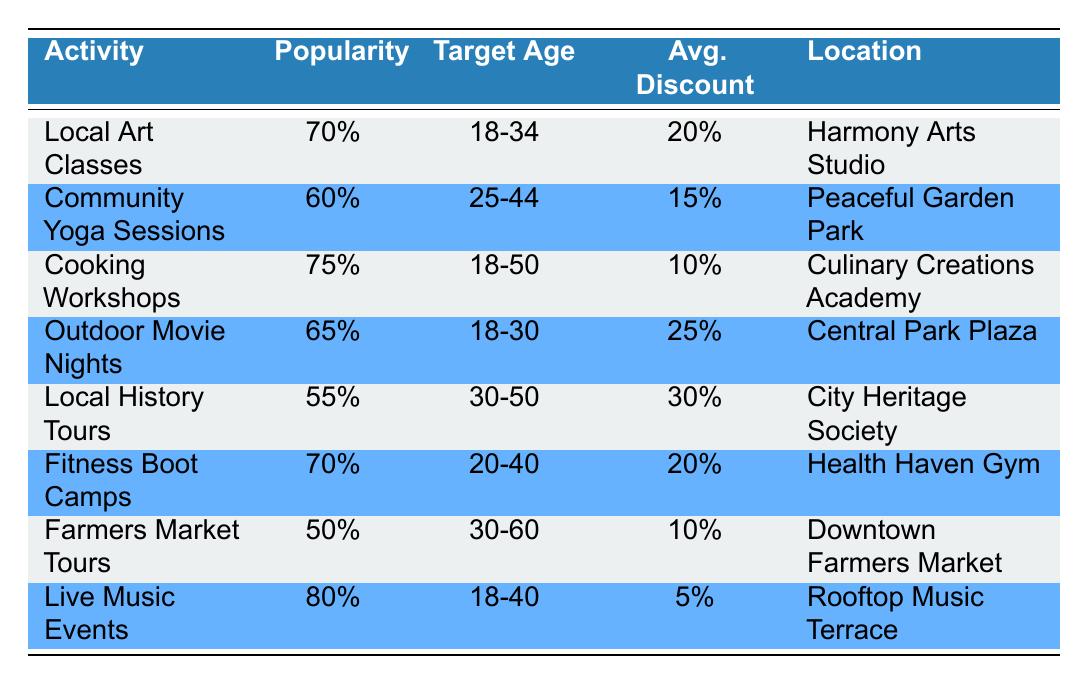What is the most popular activity among the target audience? Looking at the popularity column, we see that Live Music Events has the highest popularity at 80%.
Answer: Live Music Events Which activity offers the highest average discount? By reviewing the average discount column, Local History Tours offers the highest discount at 30%.
Answer: Local History Tours How many activities are targeted at the age group 30-50? The age groups for each activity are checked, and we find that Local History Tours and Farmers Market Tours both target the 30-50 age group, totaling 2.
Answer: 2 What is the average popularity of activities targeted at the age group 18-34? The activities targeted at the 18-34 age group are Local Art Classes, Outdoor Movie Nights, and Live Music Events, with popularity scores of 70, 65, and 80 respectively. The average is (70 + 65 + 80) / 3 = 215 / 3 = 71.67.
Answer: 71.67 Are Cooking Workshops targeted at a specific age group? Yes, Cooking Workshops are aimed at the age group 18-50, as indicated in the target age column.
Answer: Yes What is the difference in popularity between Community Yoga Sessions and Fitness Boot Camps? Community Yoga Sessions has a popularity of 60, while Fitness Boot Camps has a popularity of 70. The difference is 70 - 60 = 10.
Answer: 10 Which activity has the lowest popularity and what is it? By examining the popularity column, Farmers Market Tours has the lowest popularity rating at 50.
Answer: Farmers Market Tours What is the total number of activities that offer a discount greater than 20%? The activities with discounts greater than 20% are Local Art Classes (20%), Fitness Boot Camps (20%), Outdoor Movie Nights (25%), and Local History Tours (30%). Therefore, there are 4 activities in total.
Answer: 4 Which activity with an average discount of 10% targets the age group 30-60? Farmers Market Tours is the only activity that targets the 30-60 age group and has an average discount of 10%.
Answer: Farmers Market Tours 